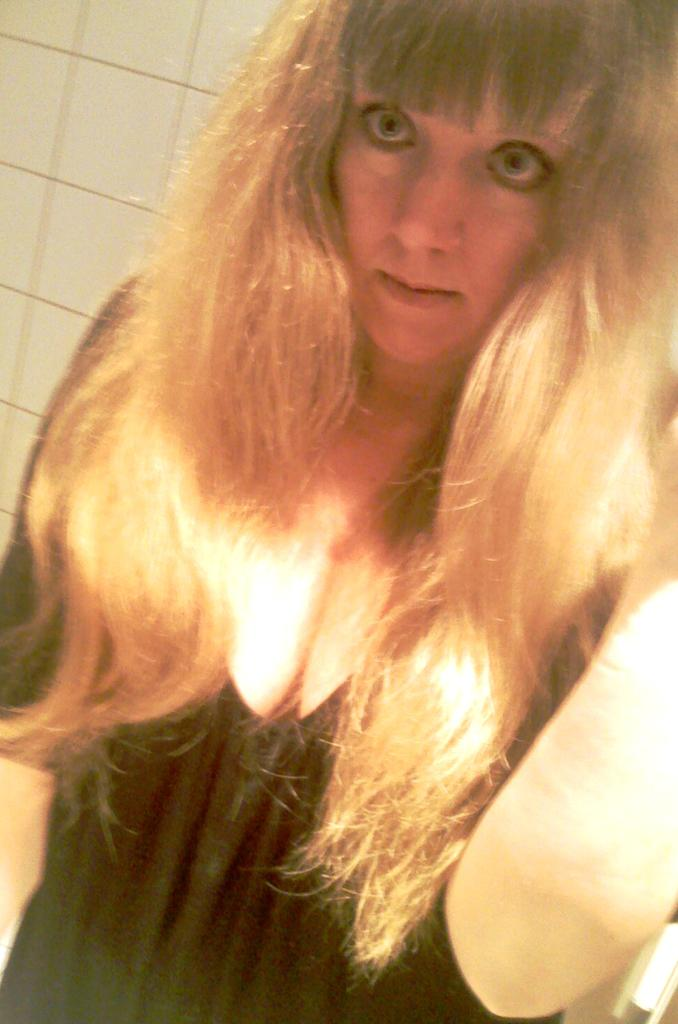Who is present in the image? There is a woman in the image. What is the woman wearing? The woman is wearing a black dress. What is the woman doing in the image? The woman is looking at something. What can be seen in the background of the image? There is a wall in the background of the image. What type of tooth is visible in the image? There is no tooth visible in the image. What kind of fowl can be seen in the image? There is no fowl present in the image. 